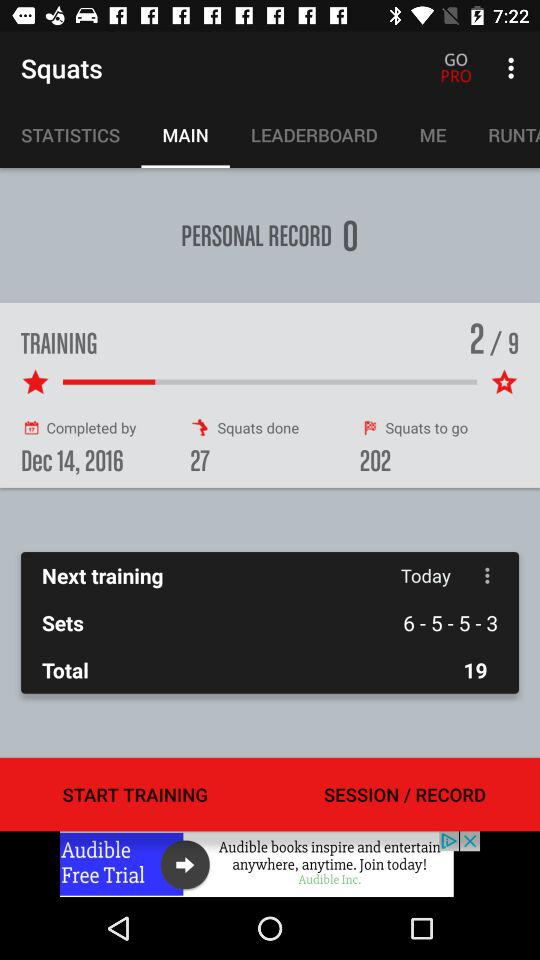How many squats are there remaining? There are 202 squats remaining. 